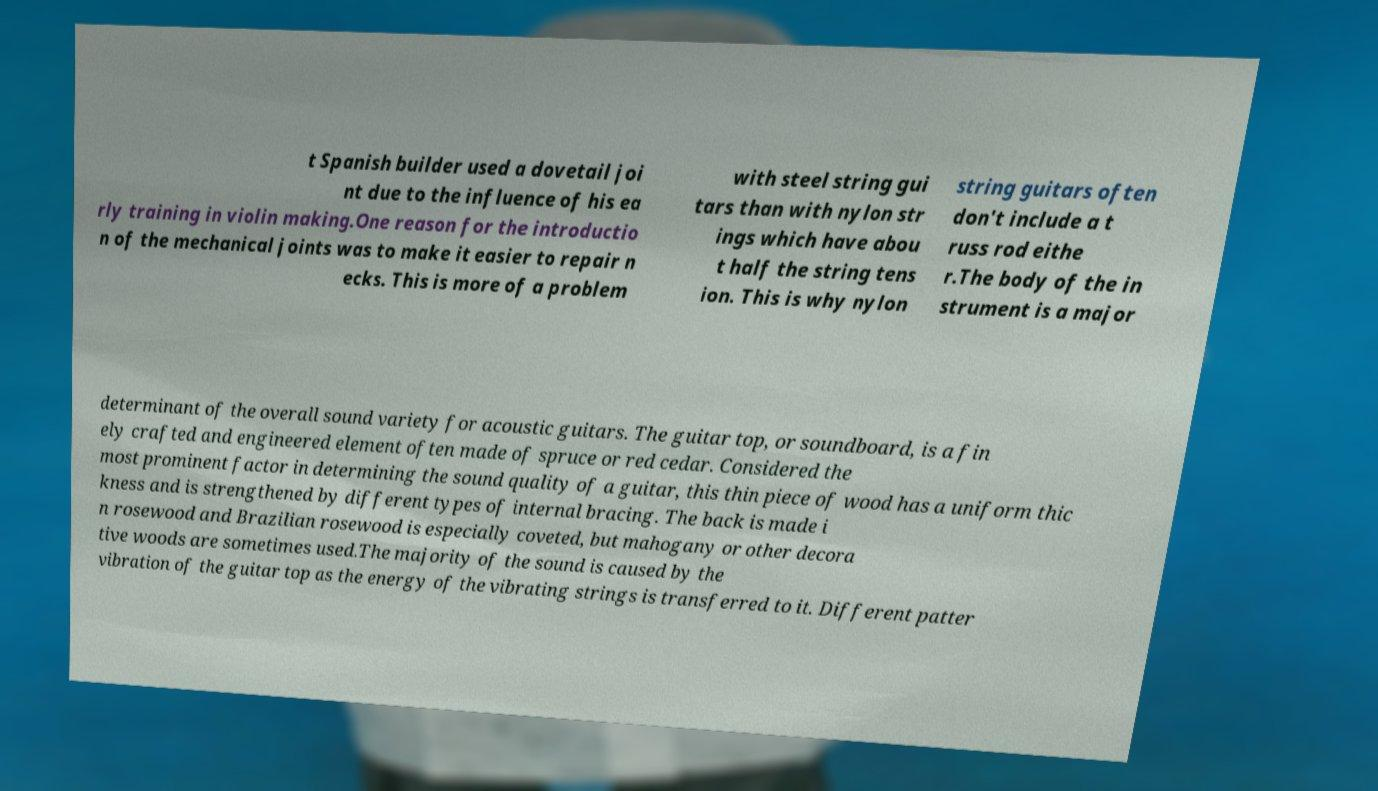Can you accurately transcribe the text from the provided image for me? t Spanish builder used a dovetail joi nt due to the influence of his ea rly training in violin making.One reason for the introductio n of the mechanical joints was to make it easier to repair n ecks. This is more of a problem with steel string gui tars than with nylon str ings which have abou t half the string tens ion. This is why nylon string guitars often don't include a t russ rod eithe r.The body of the in strument is a major determinant of the overall sound variety for acoustic guitars. The guitar top, or soundboard, is a fin ely crafted and engineered element often made of spruce or red cedar. Considered the most prominent factor in determining the sound quality of a guitar, this thin piece of wood has a uniform thic kness and is strengthened by different types of internal bracing. The back is made i n rosewood and Brazilian rosewood is especially coveted, but mahogany or other decora tive woods are sometimes used.The majority of the sound is caused by the vibration of the guitar top as the energy of the vibrating strings is transferred to it. Different patter 